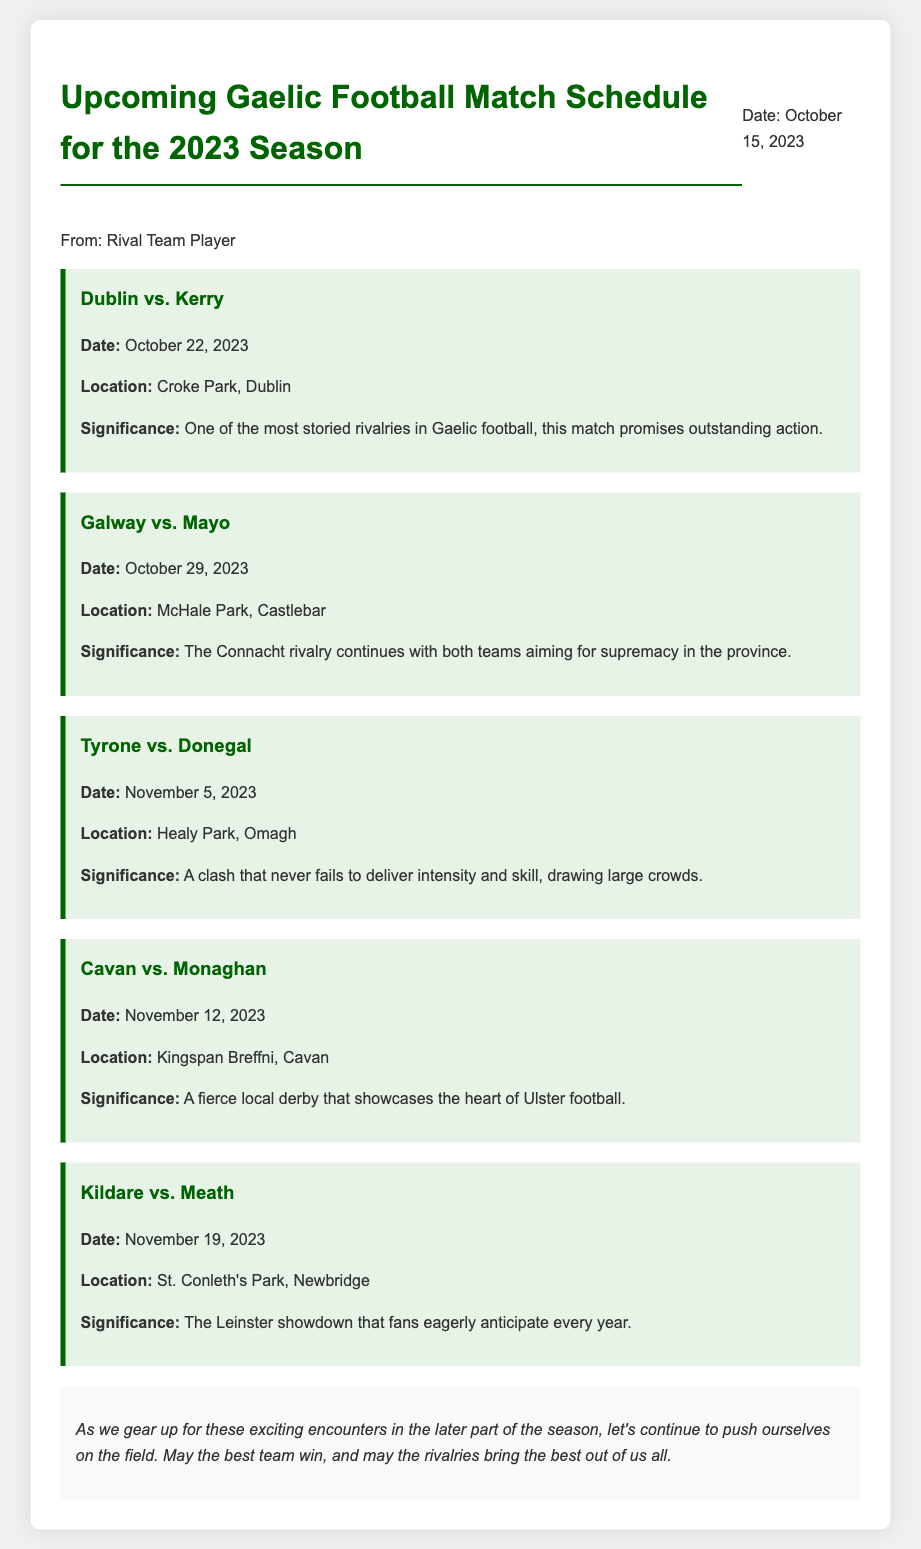What is the first match listed? The first match listed is Dublin vs. Kerry.
Answer: Dublin vs. Kerry When is the Galway vs. Mayo match scheduled? The match is scheduled for October 29, 2023.
Answer: October 29, 2023 Where will the Tyrone vs. Donegal match be held? The match will be held at Healy Park, Omagh.
Answer: Healy Park, Omagh What is the significance of the Cavan vs. Monaghan match? The match is a fierce local derby showcasing the heart of Ulster football.
Answer: A fierce local derby showcasing the heart of Ulster football How many matches are listed in the document? The document lists a total of five matches.
Answer: Five Which rivalry includes the date of November 19, 2023? The rivalry is Kildare vs. Meath.
Answer: Kildare vs. Meath What is the color theme of the memo? The color theme includes green and white tones, emphasizing Gaelic football.
Answer: Green and white tones What does the conclusion encourage players to do? The conclusion encourages players to continue pushing themselves on the field.
Answer: Continue pushing themselves on the field What is the title of the document? The title of the document is Upcoming Gaelic Football Match Schedule for the 2023 Season.
Answer: Upcoming Gaelic Football Match Schedule for the 2023 Season 